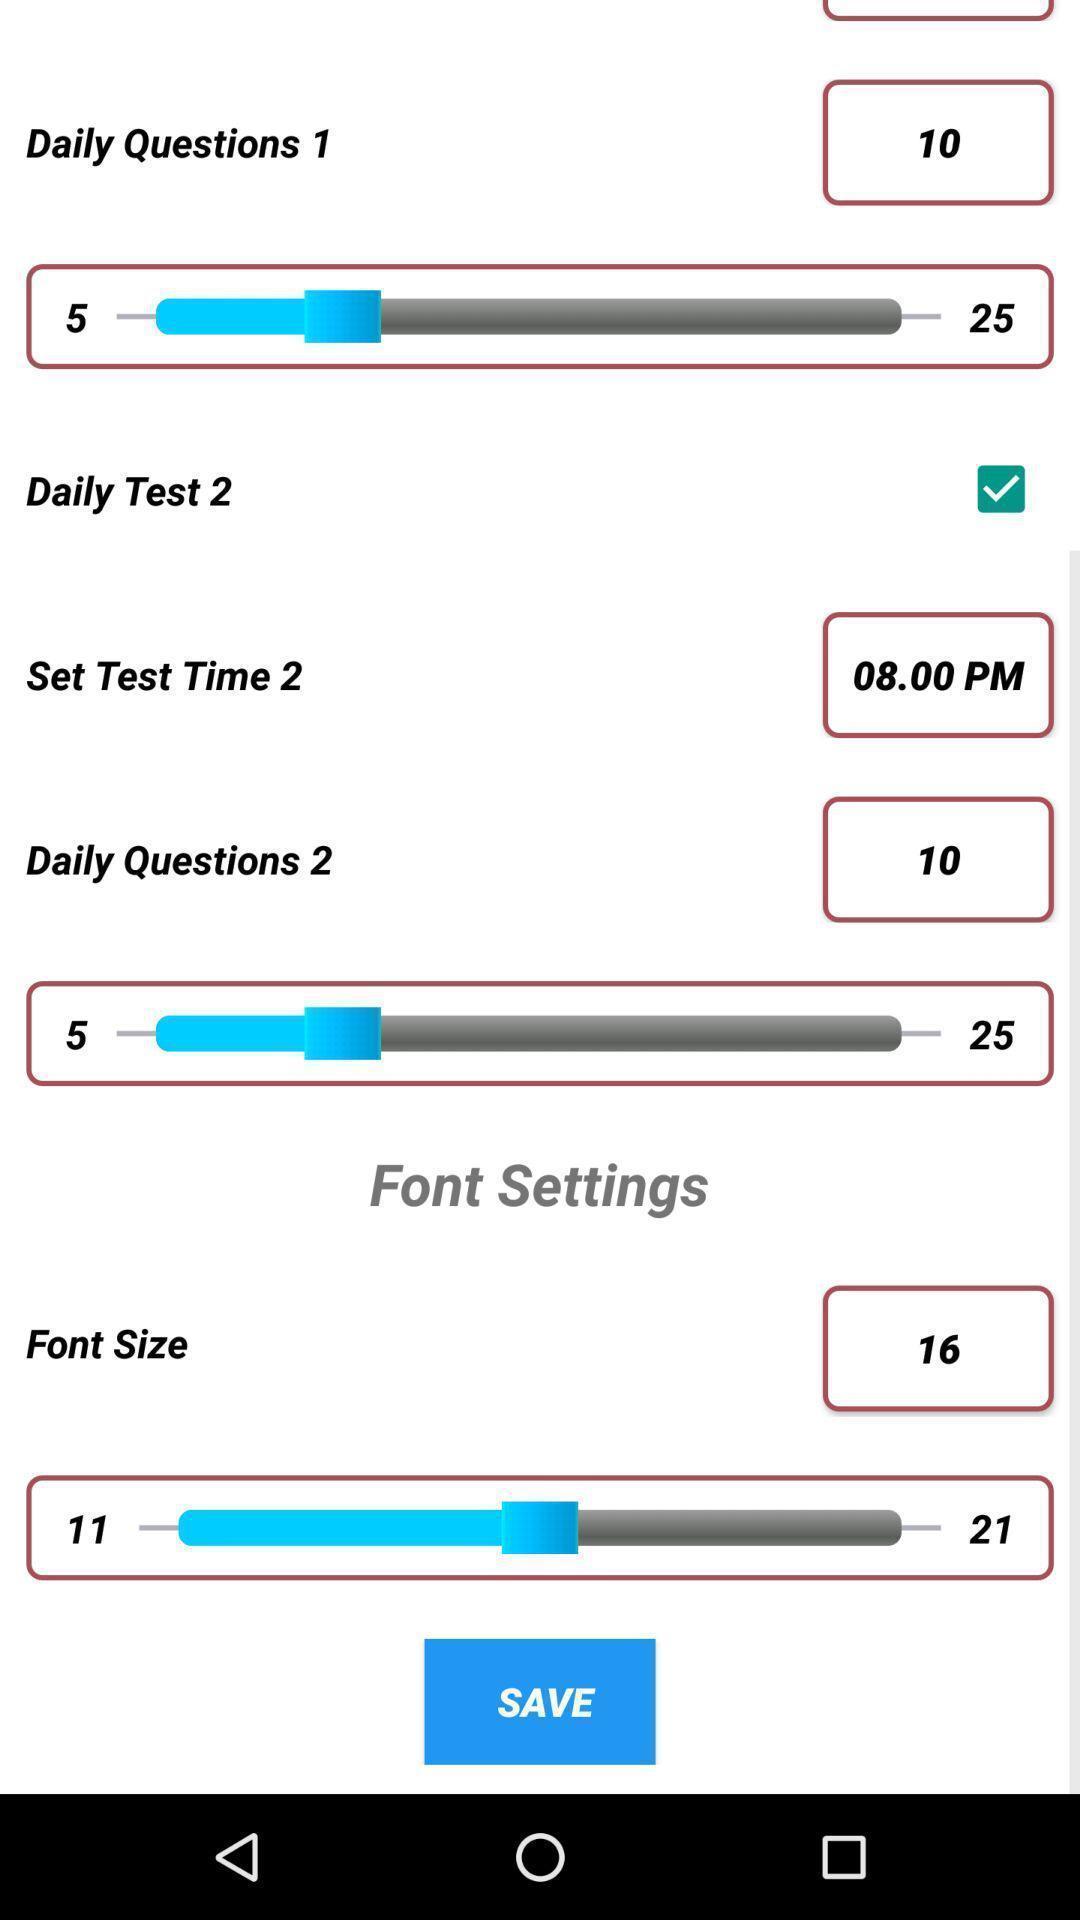Explain the elements present in this screenshot. Screen displaying multiple features with scroll bars. 